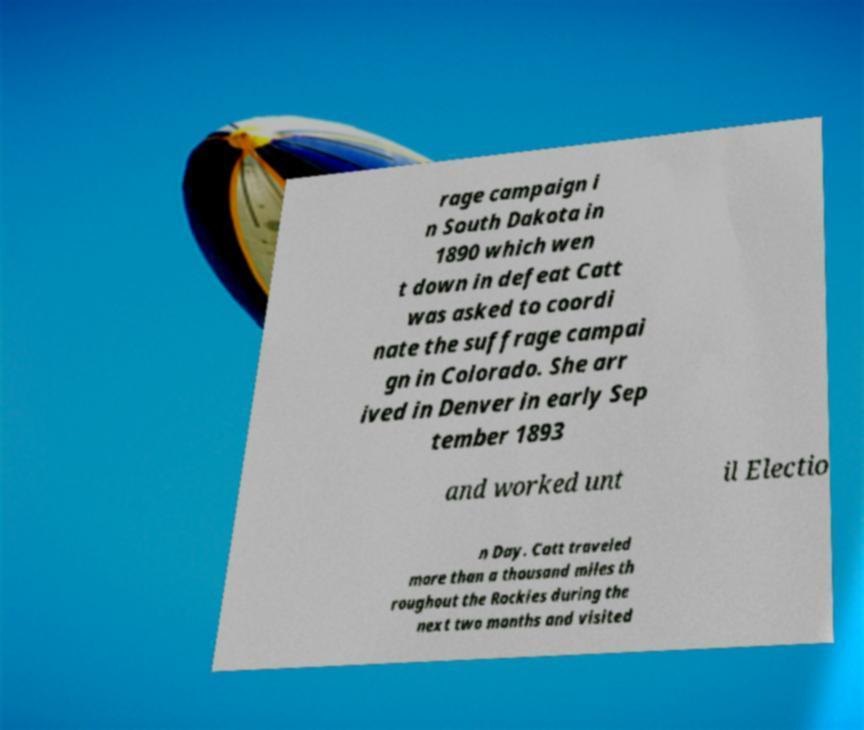Please identify and transcribe the text found in this image. rage campaign i n South Dakota in 1890 which wen t down in defeat Catt was asked to coordi nate the suffrage campai gn in Colorado. She arr ived in Denver in early Sep tember 1893 and worked unt il Electio n Day. Catt traveled more than a thousand miles th roughout the Rockies during the next two months and visited 